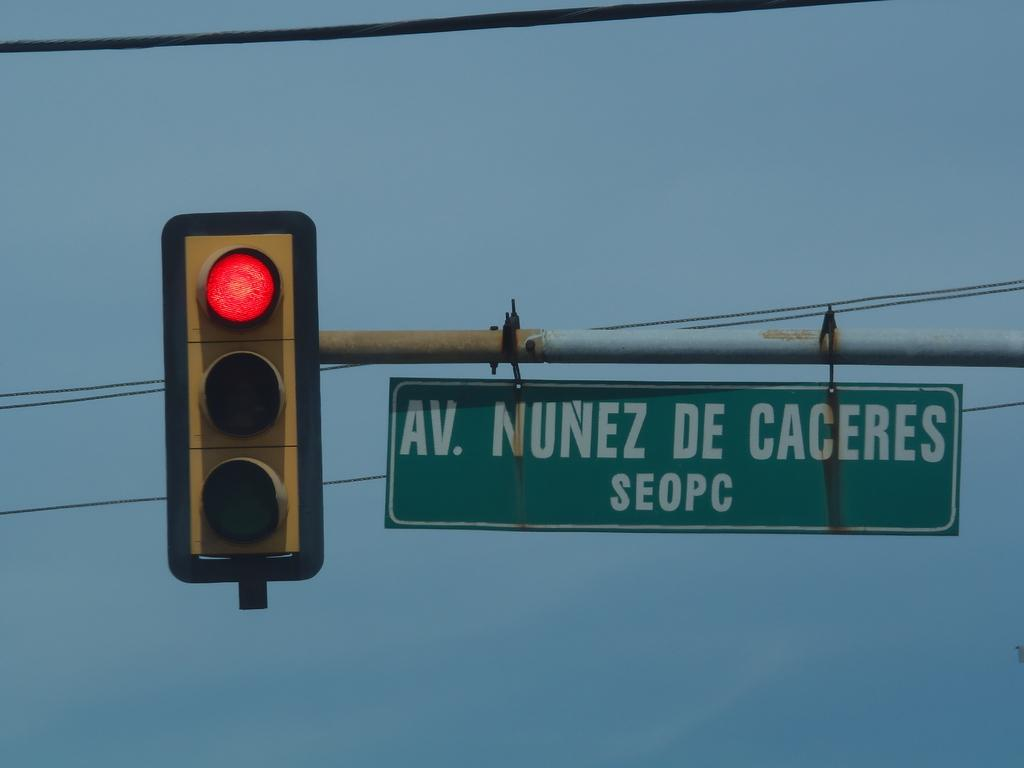<image>
Offer a succinct explanation of the picture presented. A stop light by a sign saying AV NUNEZ DE CACERES. 